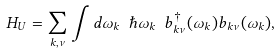Convert formula to latex. <formula><loc_0><loc_0><loc_500><loc_500>H _ { U } = \sum _ { { k } , \nu } \int d \omega _ { k } \ \hbar { \omega } _ { k } \ b _ { { k } \nu } ^ { \dagger } ( \omega _ { k } ) b _ { { k } \nu } ( \omega _ { k } ) ,</formula> 